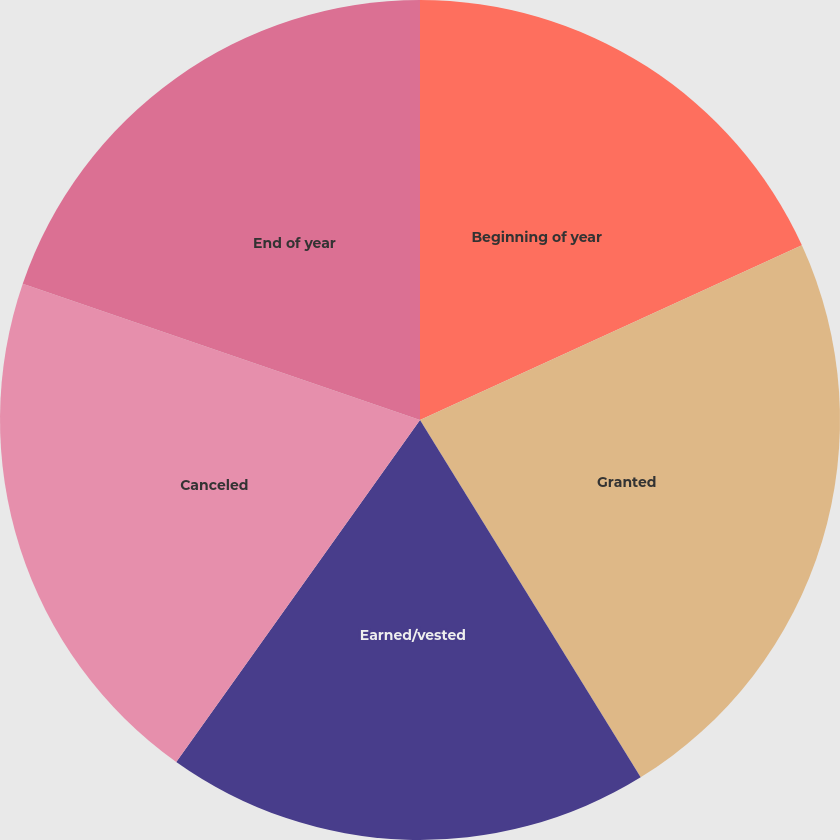Convert chart. <chart><loc_0><loc_0><loc_500><loc_500><pie_chart><fcel>Beginning of year<fcel>Granted<fcel>Earned/vested<fcel>Canceled<fcel>End of year<nl><fcel>18.17%<fcel>23.03%<fcel>18.66%<fcel>20.41%<fcel>19.74%<nl></chart> 